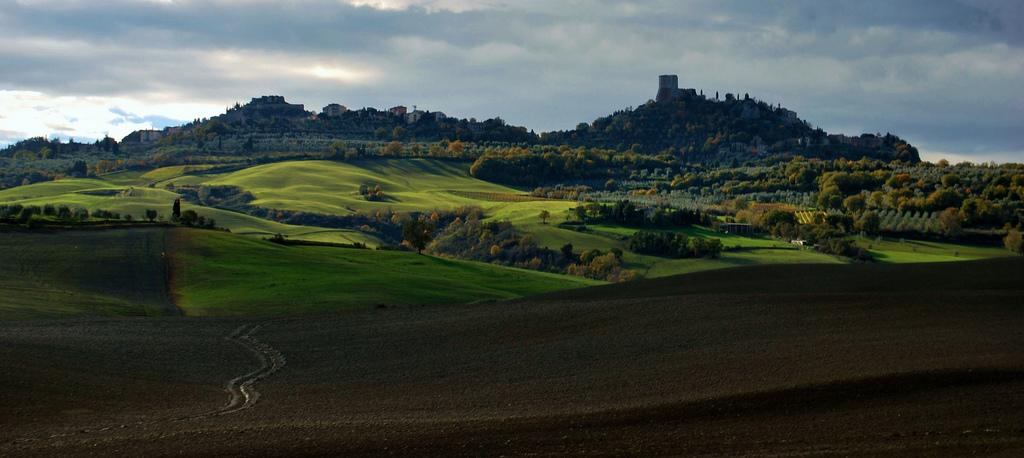What type of landscape is depicted in the image? There is a grassland in the image. What other natural features can be seen in the image? There are trees and mountains in the image. What is visible in the background of the image? The sky is visible in the image. What type of alarm can be heard going off in the image? There is no alarm present in the image, as it is a still image and cannot produce sound. 